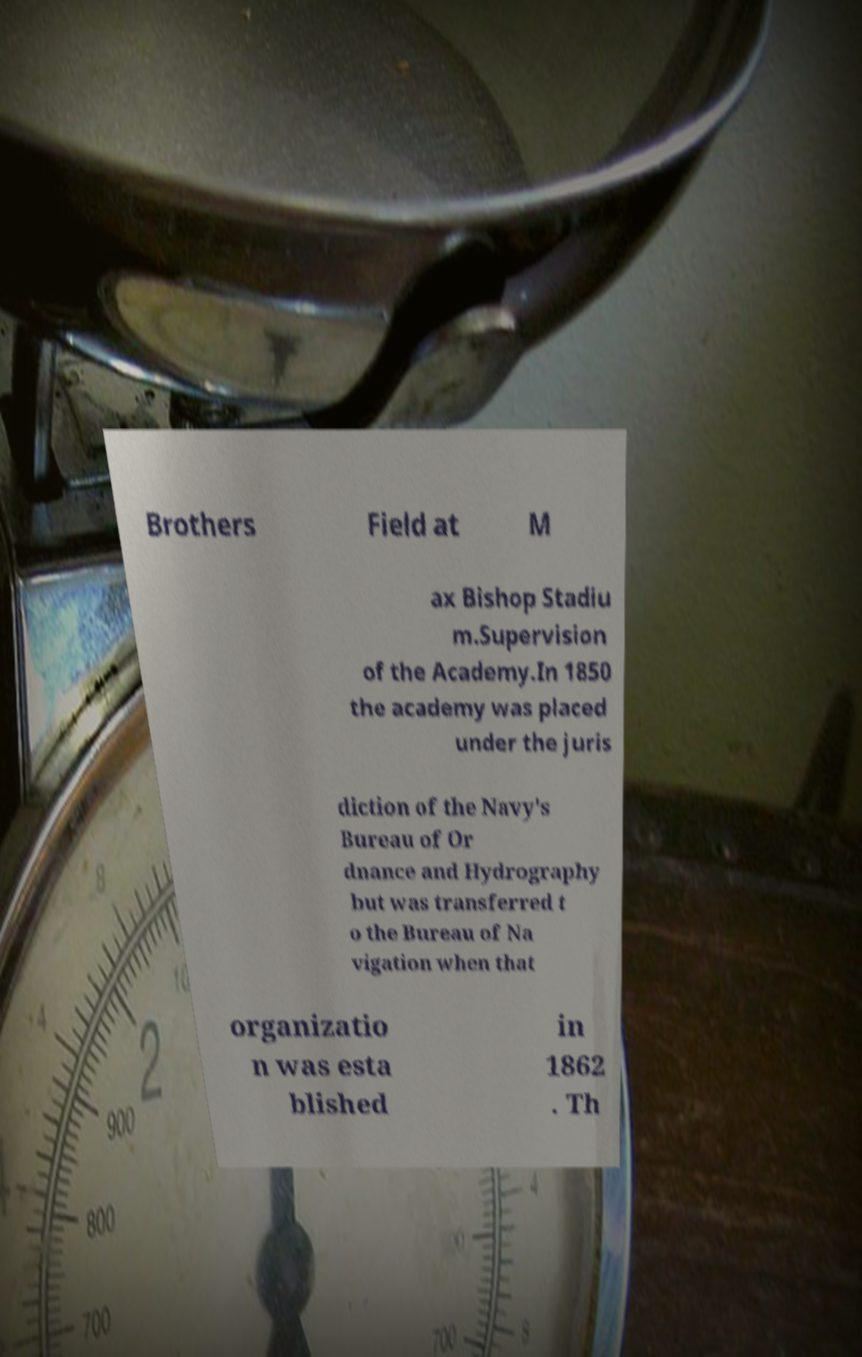What messages or text are displayed in this image? I need them in a readable, typed format. Brothers Field at M ax Bishop Stadiu m.Supervision of the Academy.In 1850 the academy was placed under the juris diction of the Navy's Bureau of Or dnance and Hydrography but was transferred t o the Bureau of Na vigation when that organizatio n was esta blished in 1862 . Th 